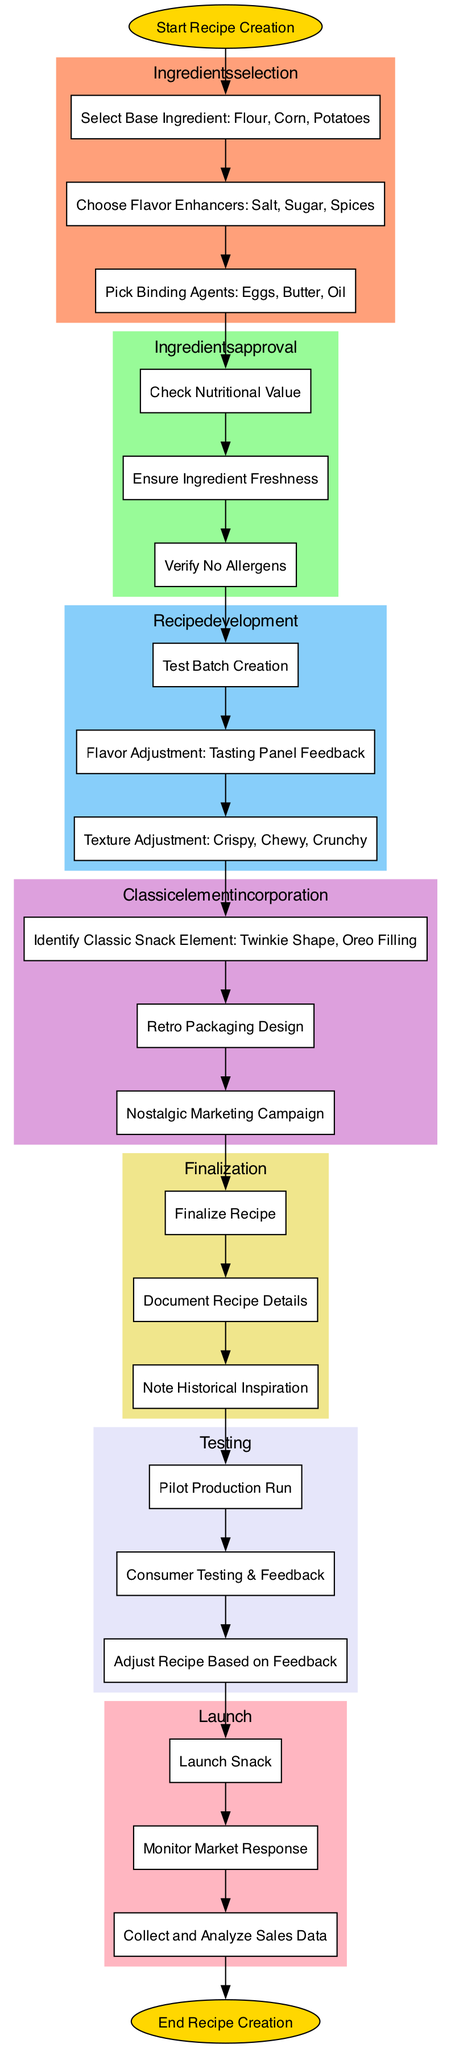What is the first step in the recipe creation flow? The diagram starts with the node labeled "Start Recipe Creation," indicating the beginning of the process.
Answer: Start Recipe Creation How many steps are in the ingredients selection phase? The ingredients selection phase includes three distinct steps: selecting the base ingredient, choosing flavor enhancers, and picking binding agents.
Answer: 3 What color is used to represent the finalization stage? The finalization stage is represented in a light yellow color, specifically identified as #F0E68C in the diagram.
Answer: Light yellow What is the last step before the snack launch? The last step before the snack launch is "Adjust Recipe Based on Feedback," indicating it is an important review phase before distribution.
Answer: Adjust Recipe Based on Feedback Which classic element involves retro packaging design? The classic element that involves retro packaging design is labeled "Retro Packaging Design" under the classic element incorporation phase.
Answer: Retro Packaging Design How many main processes are there in the diagram? There are seven main processes outlined in the diagram, each represented by its respective section in the flowchart.
Answer: 7 Which step follows the texture adjustment in recipe development? The step that follows texture adjustment in recipe development is "Classic Element Incorporation," indicating a transition from developing the recipe to integrating nostalgic aspects.
Answer: Classic Element Incorporation What is monitored immediately after launching the snack? "Monitor Market Response" is the first step monitored immediately after the snack is launched.
Answer: Monitor Market Response What connects the ingredients selection to the ingredients approval? An edge connects "Select Base Ingredient: Flour, Corn, Potatoes" to the first step of ingredients approval, indicating a direct flow from one stage to the next.
Answer: An edge 